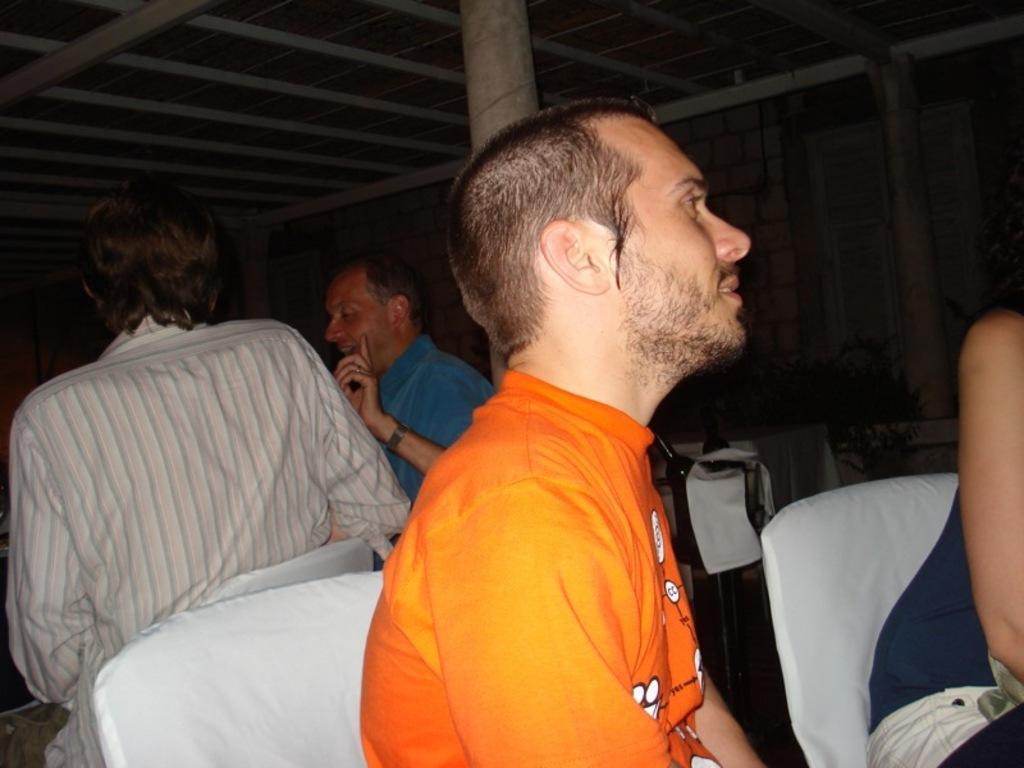Please provide a concise description of this image. As we can see in the image there are chairs and few people here and there. The image is little dark. 